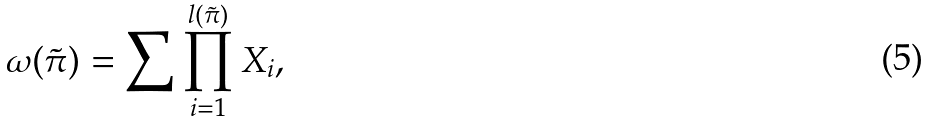Convert formula to latex. <formula><loc_0><loc_0><loc_500><loc_500>\omega ( \tilde { \pi } ) = \sum \prod _ { i = 1 } ^ { l ( \tilde { \pi } ) } X _ { i } ,</formula> 